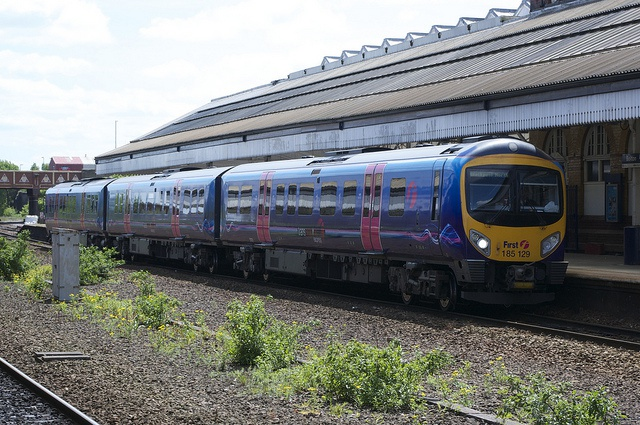Describe the objects in this image and their specific colors. I can see a train in white, black, gray, and navy tones in this image. 